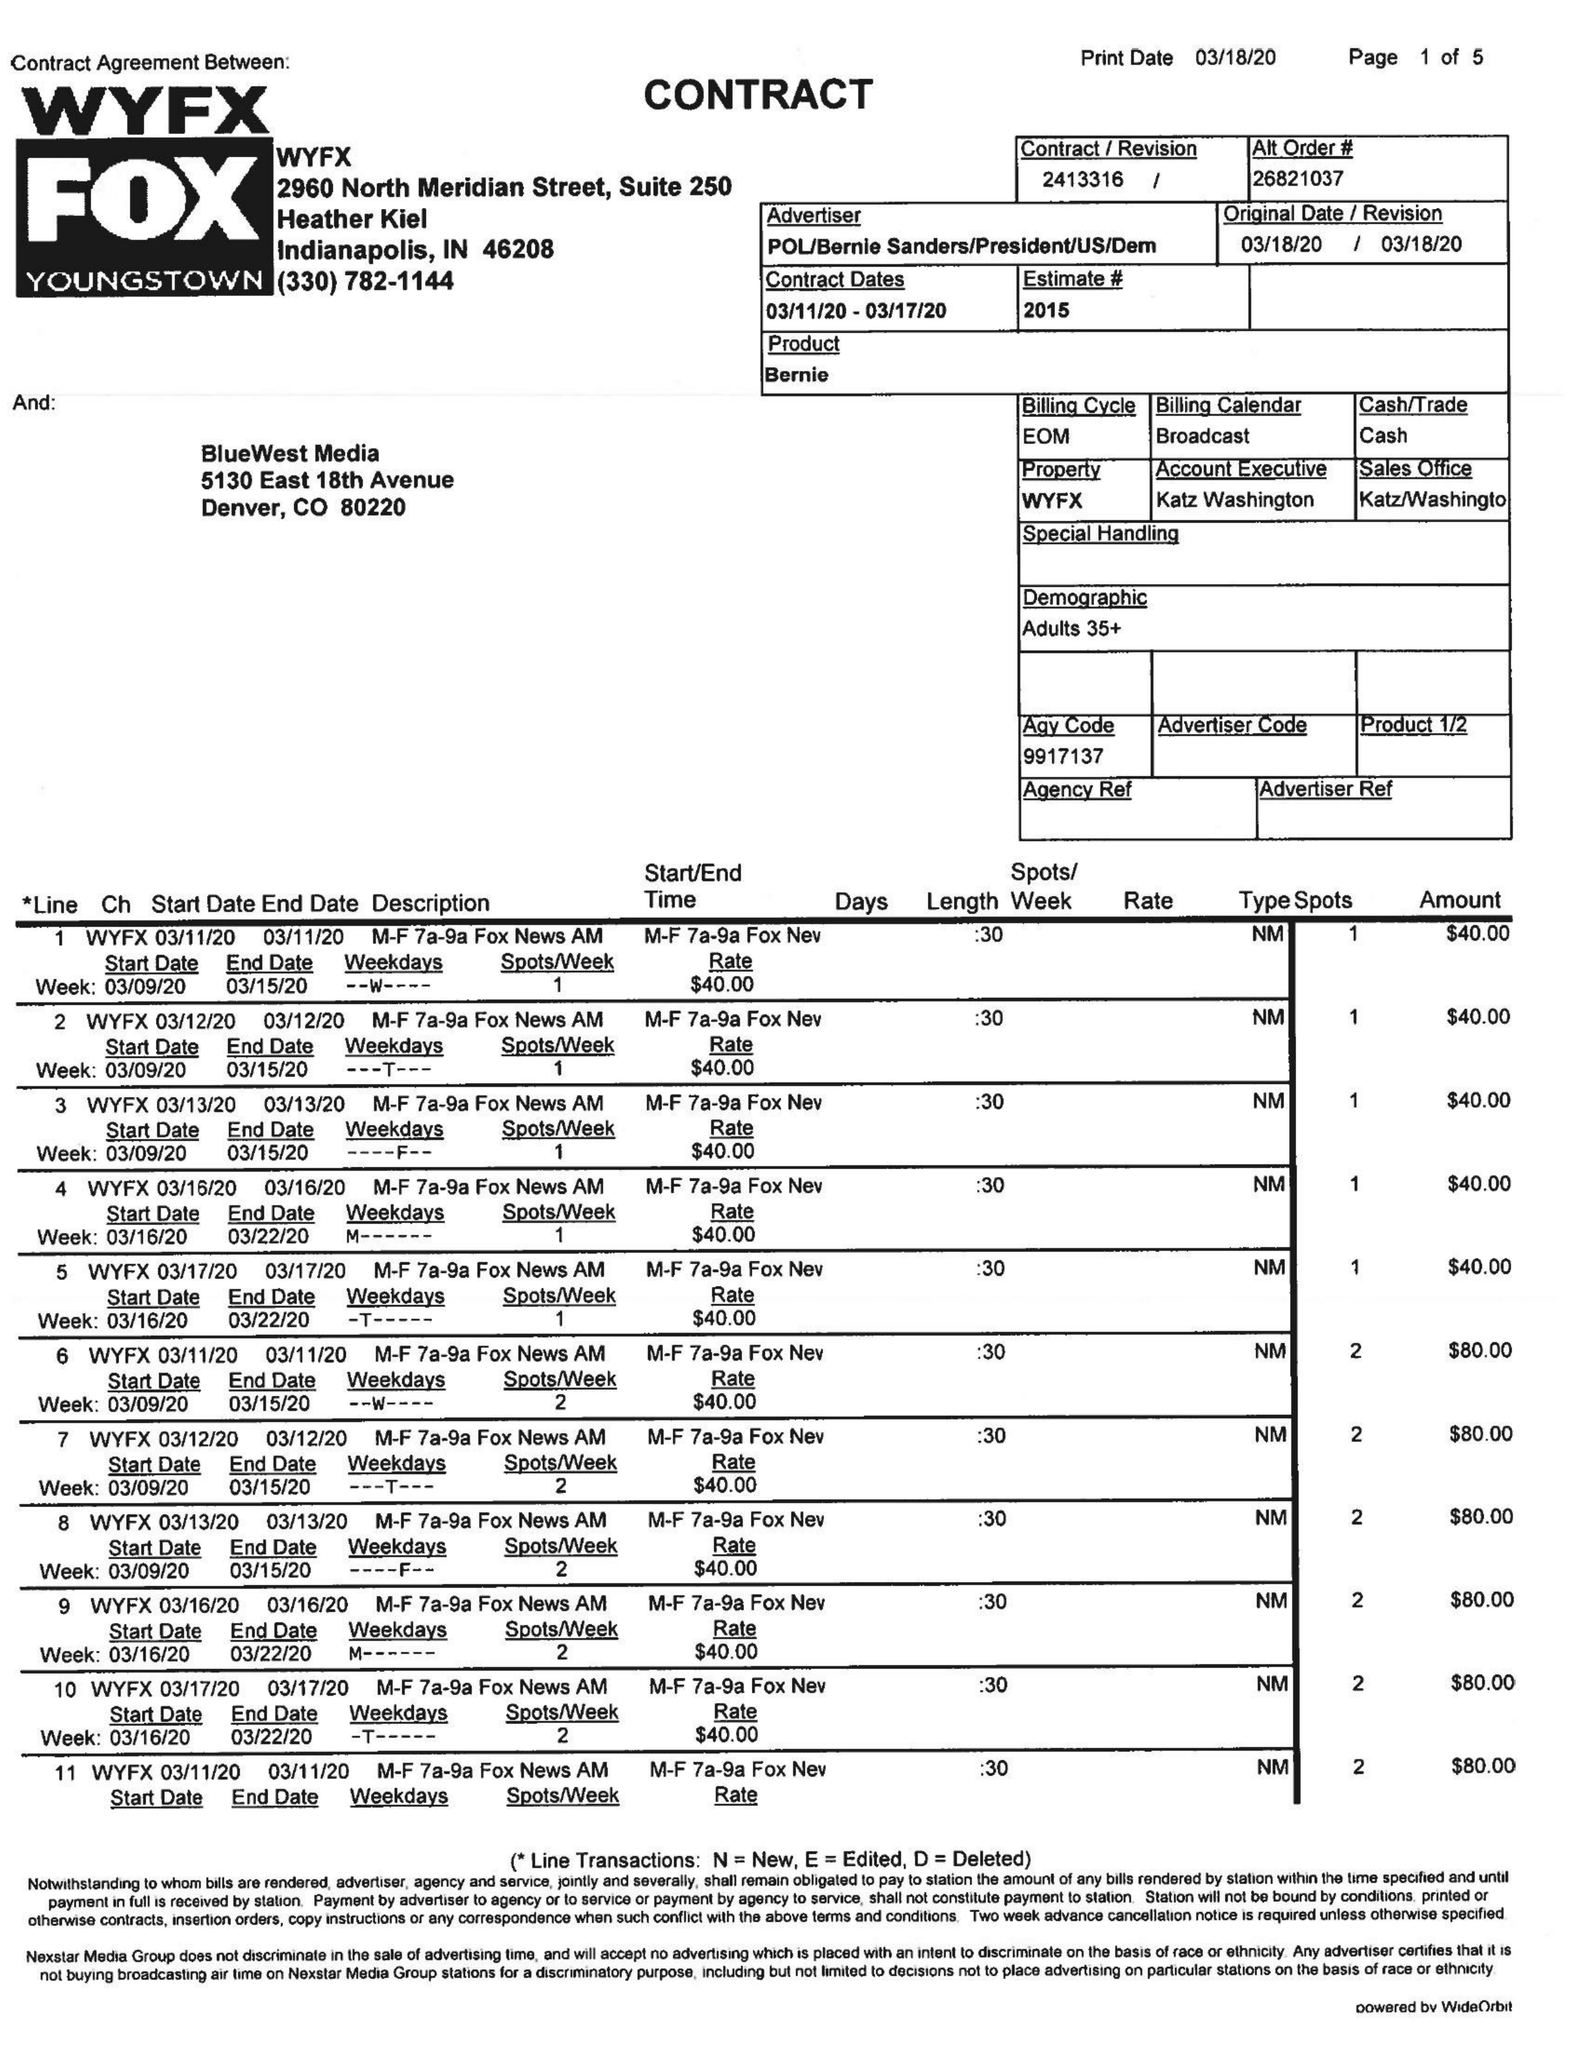What is the value for the contract_num?
Answer the question using a single word or phrase. 2413316 